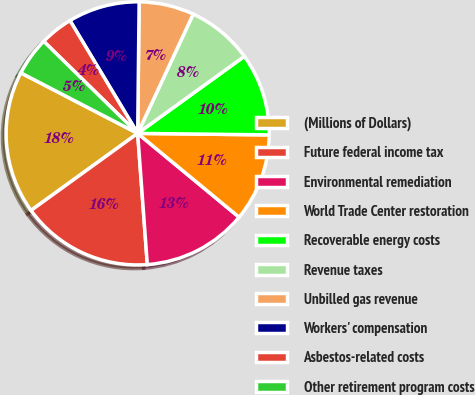<chart> <loc_0><loc_0><loc_500><loc_500><pie_chart><fcel>(Millions of Dollars)<fcel>Future federal income tax<fcel>Environmental remediation<fcel>World Trade Center restoration<fcel>Recoverable energy costs<fcel>Revenue taxes<fcel>Unbilled gas revenue<fcel>Workers' compensation<fcel>Asbestos-related costs<fcel>Other retirement program costs<nl><fcel>17.57%<fcel>16.21%<fcel>12.84%<fcel>10.81%<fcel>10.14%<fcel>8.11%<fcel>6.76%<fcel>8.78%<fcel>4.06%<fcel>4.73%<nl></chart> 